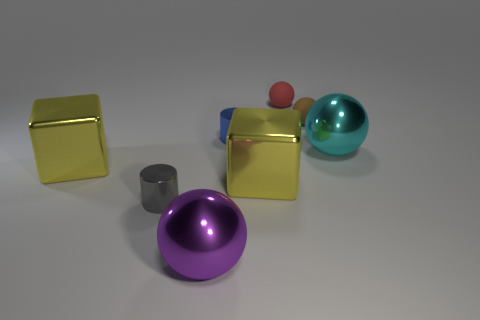Does the cylinder that is in front of the large cyan ball have the same material as the purple object?
Offer a very short reply. Yes. There is a metal ball that is the same size as the purple thing; what color is it?
Offer a terse response. Cyan. The blue thing that is made of the same material as the cyan sphere is what size?
Offer a terse response. Small. How many other objects are there of the same size as the blue metal cylinder?
Ensure brevity in your answer.  3. What material is the yellow block that is to the left of the blue object?
Your response must be concise. Metal. There is a metal thing behind the large ball behind the cylinder left of the large purple ball; what shape is it?
Your answer should be compact. Cylinder. Does the cyan sphere have the same size as the red matte sphere?
Keep it short and to the point. No. How many objects are either small purple metal cylinders or tiny things on the right side of the tiny gray metal cylinder?
Your answer should be compact. 3. How many objects are shiny cylinders that are in front of the large cyan metal thing or small cylinders in front of the large cyan sphere?
Your answer should be very brief. 1. Are there any large shiny things to the left of the red ball?
Keep it short and to the point. Yes. 